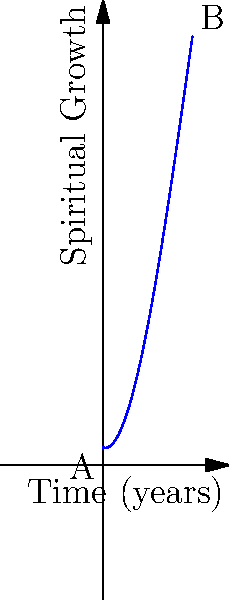The curve above represents the spiritual growth of an individual over time, modeled by the function $f(x) = -0.1x^3 + 1.5x^2 - 0.4x + 1$, where $x$ is time in years and $f(x)$ is the level of spiritual growth. What is the total change in spiritual growth from point A to point B? To find the total change in spiritual growth from point A to point B, we need to:

1. Calculate $f(0)$ (point A):
   $f(0) = -0.1(0)^3 + 1.5(0)^2 - 0.4(0) + 1 = 1$

2. Calculate $f(5)$ (point B):
   $f(5) = -0.1(5)^3 + 1.5(5)^2 - 0.4(5) + 1$
   $= -12.5 + 37.5 - 2 + 1$
   $= 24$

3. Calculate the difference between $f(5)$ and $f(0)$:
   Total change = $f(5) - f(0) = 24 - 1 = 23$

Therefore, the total change in spiritual growth from point A to point B is 23 units.
Answer: 23 units 